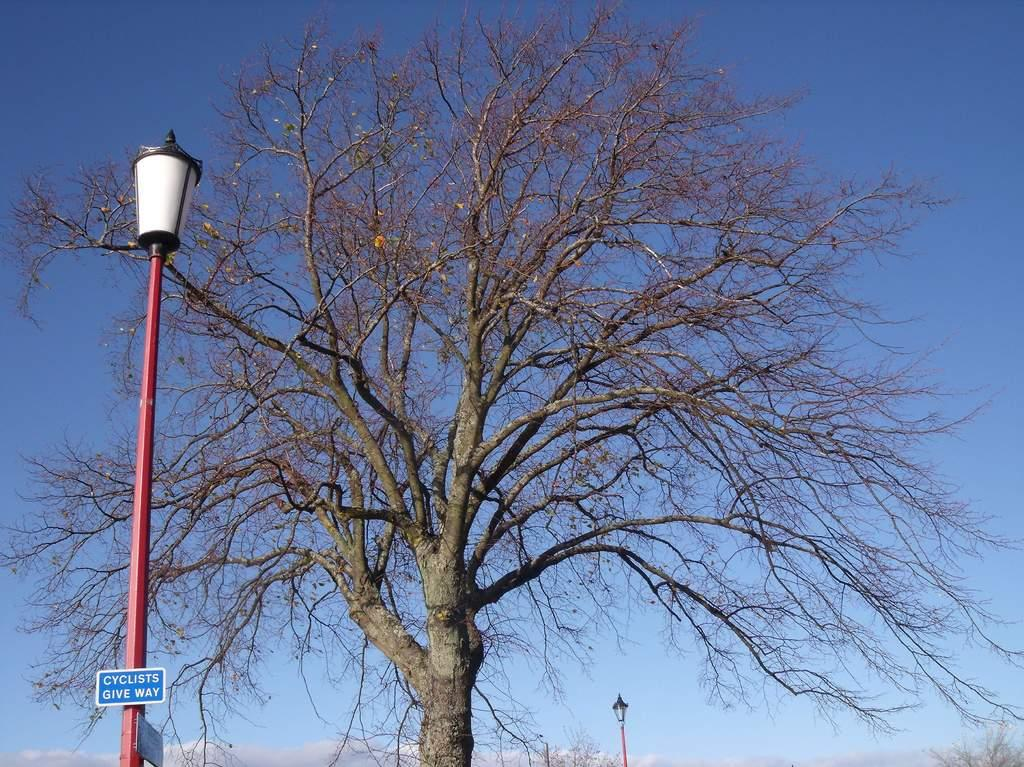What type of vegetation can be seen in the image? There are trees in the image. What type of lighting is present in the image? There are pole lights in the image. What is the color of the board in the image? The board is blue in the image. What is written on the board in the image? The board has something written on it. What can be seen in the background of the image? The sky is visible in the background of the image. Can you see any quivering fowl on the side of the image? There is no mention of quivering fowl or any other animals in the image; it primarily features trees, pole lights, a blue color board, and the sky. 